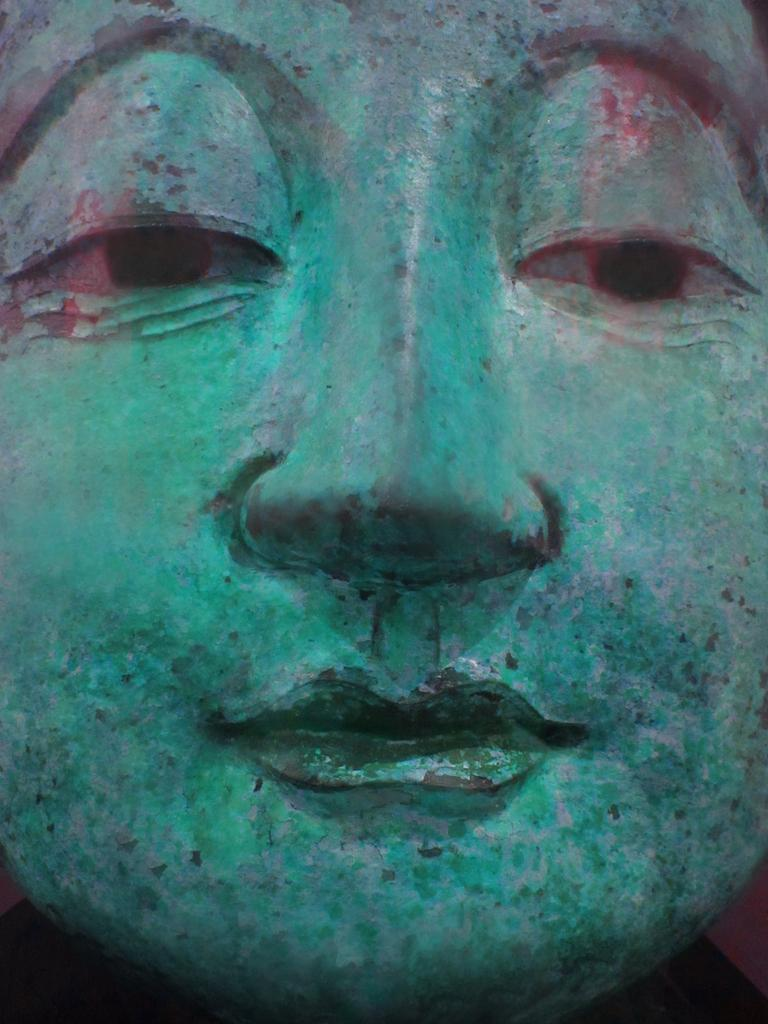What is the main subject in the image? There is a sculpture in the image. How realistic does the sculpture appear? The sculpture looks like a real image. What color is the sculpture? The sculpture is in green color. Where is the middle of the sculpture located in the image? The concept of a "middle" does not apply to a sculpture, as it is a three-dimensional object and not a linear or flat structure. What idea inspired the creation of the sculpture in the image? The image does not provide information about the inspiration or idea behind the creation of the sculpture. 